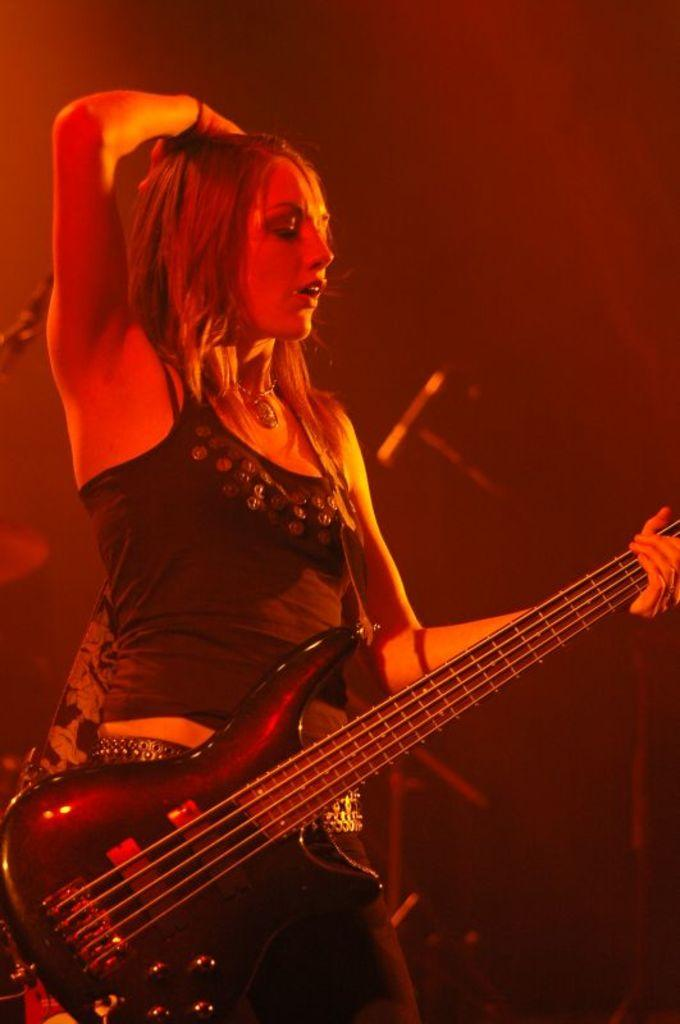Who is the main subject in the image? There is a woman in the image. What is the woman holding in the image? The woman is holding a guitar. What is the woman's posture in the image? The woman is standing. What can be seen in the background of the image? There are objects in the background of the image. What color is the girl's shirt in the image? There is no girl present in the image, only a woman. How does the woman's throat look like in the image? The image does not show the woman's throat, so it cannot be described. 